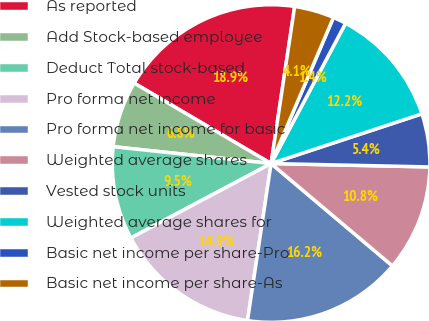<chart> <loc_0><loc_0><loc_500><loc_500><pie_chart><fcel>As reported<fcel>Add Stock-based employee<fcel>Deduct Total stock-based<fcel>Pro forma net income<fcel>Pro forma net income for basic<fcel>Weighted average shares<fcel>Vested stock units<fcel>Weighted average shares for<fcel>Basic net income per share-Pro<fcel>Basic net income per share-As<nl><fcel>18.92%<fcel>6.76%<fcel>9.46%<fcel>14.86%<fcel>16.22%<fcel>10.81%<fcel>5.41%<fcel>12.16%<fcel>1.35%<fcel>4.05%<nl></chart> 